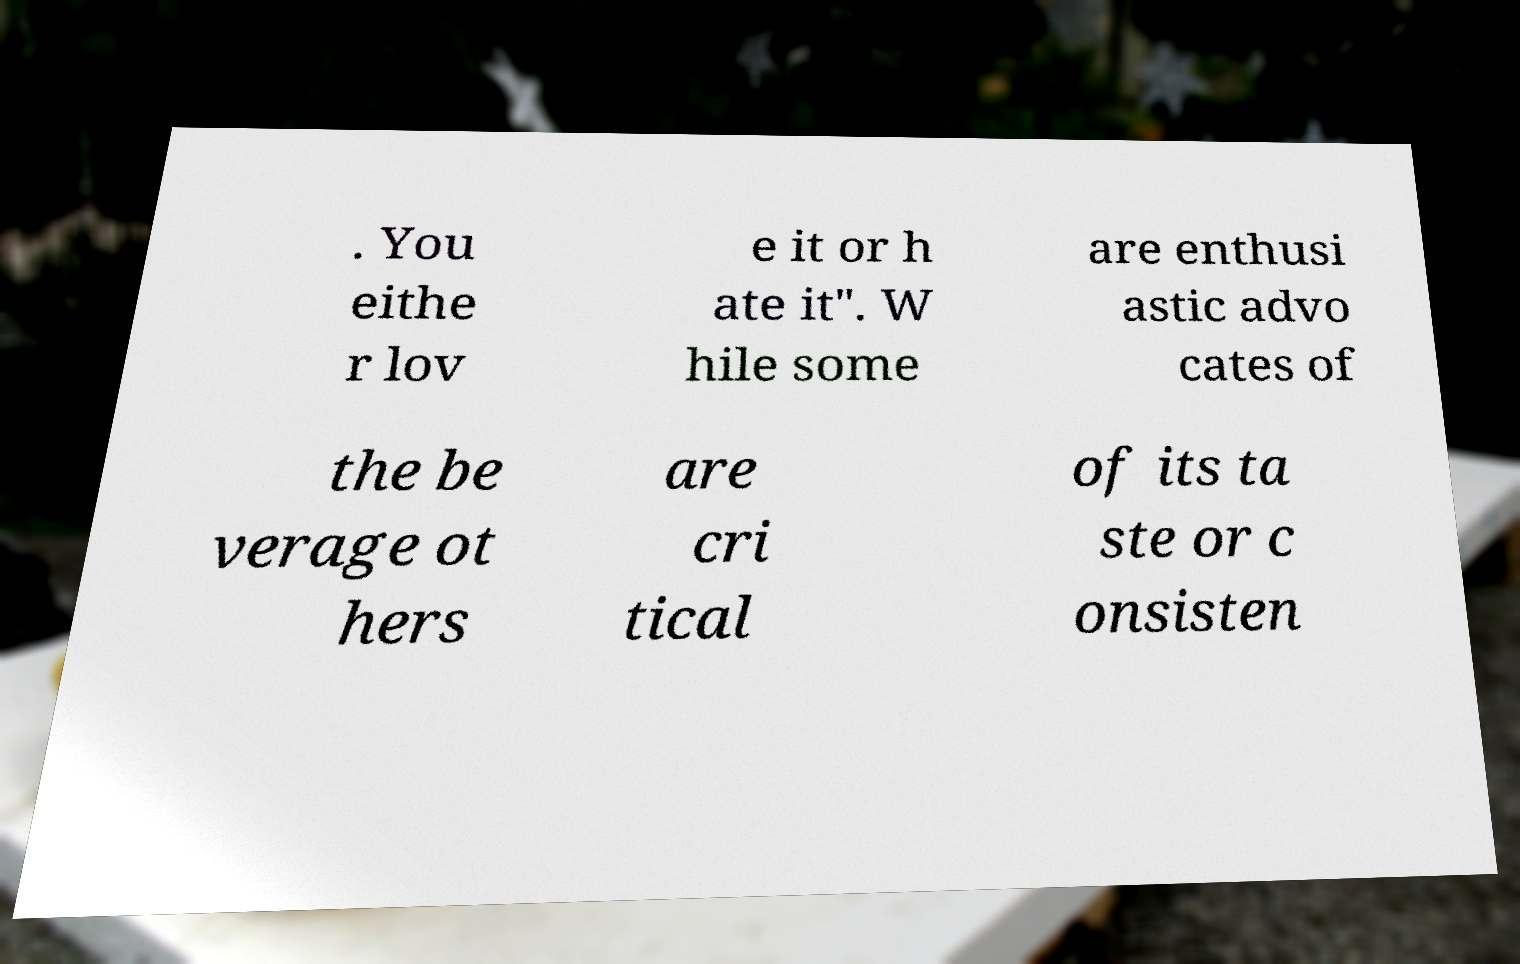Please read and relay the text visible in this image. What does it say? . You eithe r lov e it or h ate it". W hile some are enthusi astic advo cates of the be verage ot hers are cri tical of its ta ste or c onsisten 